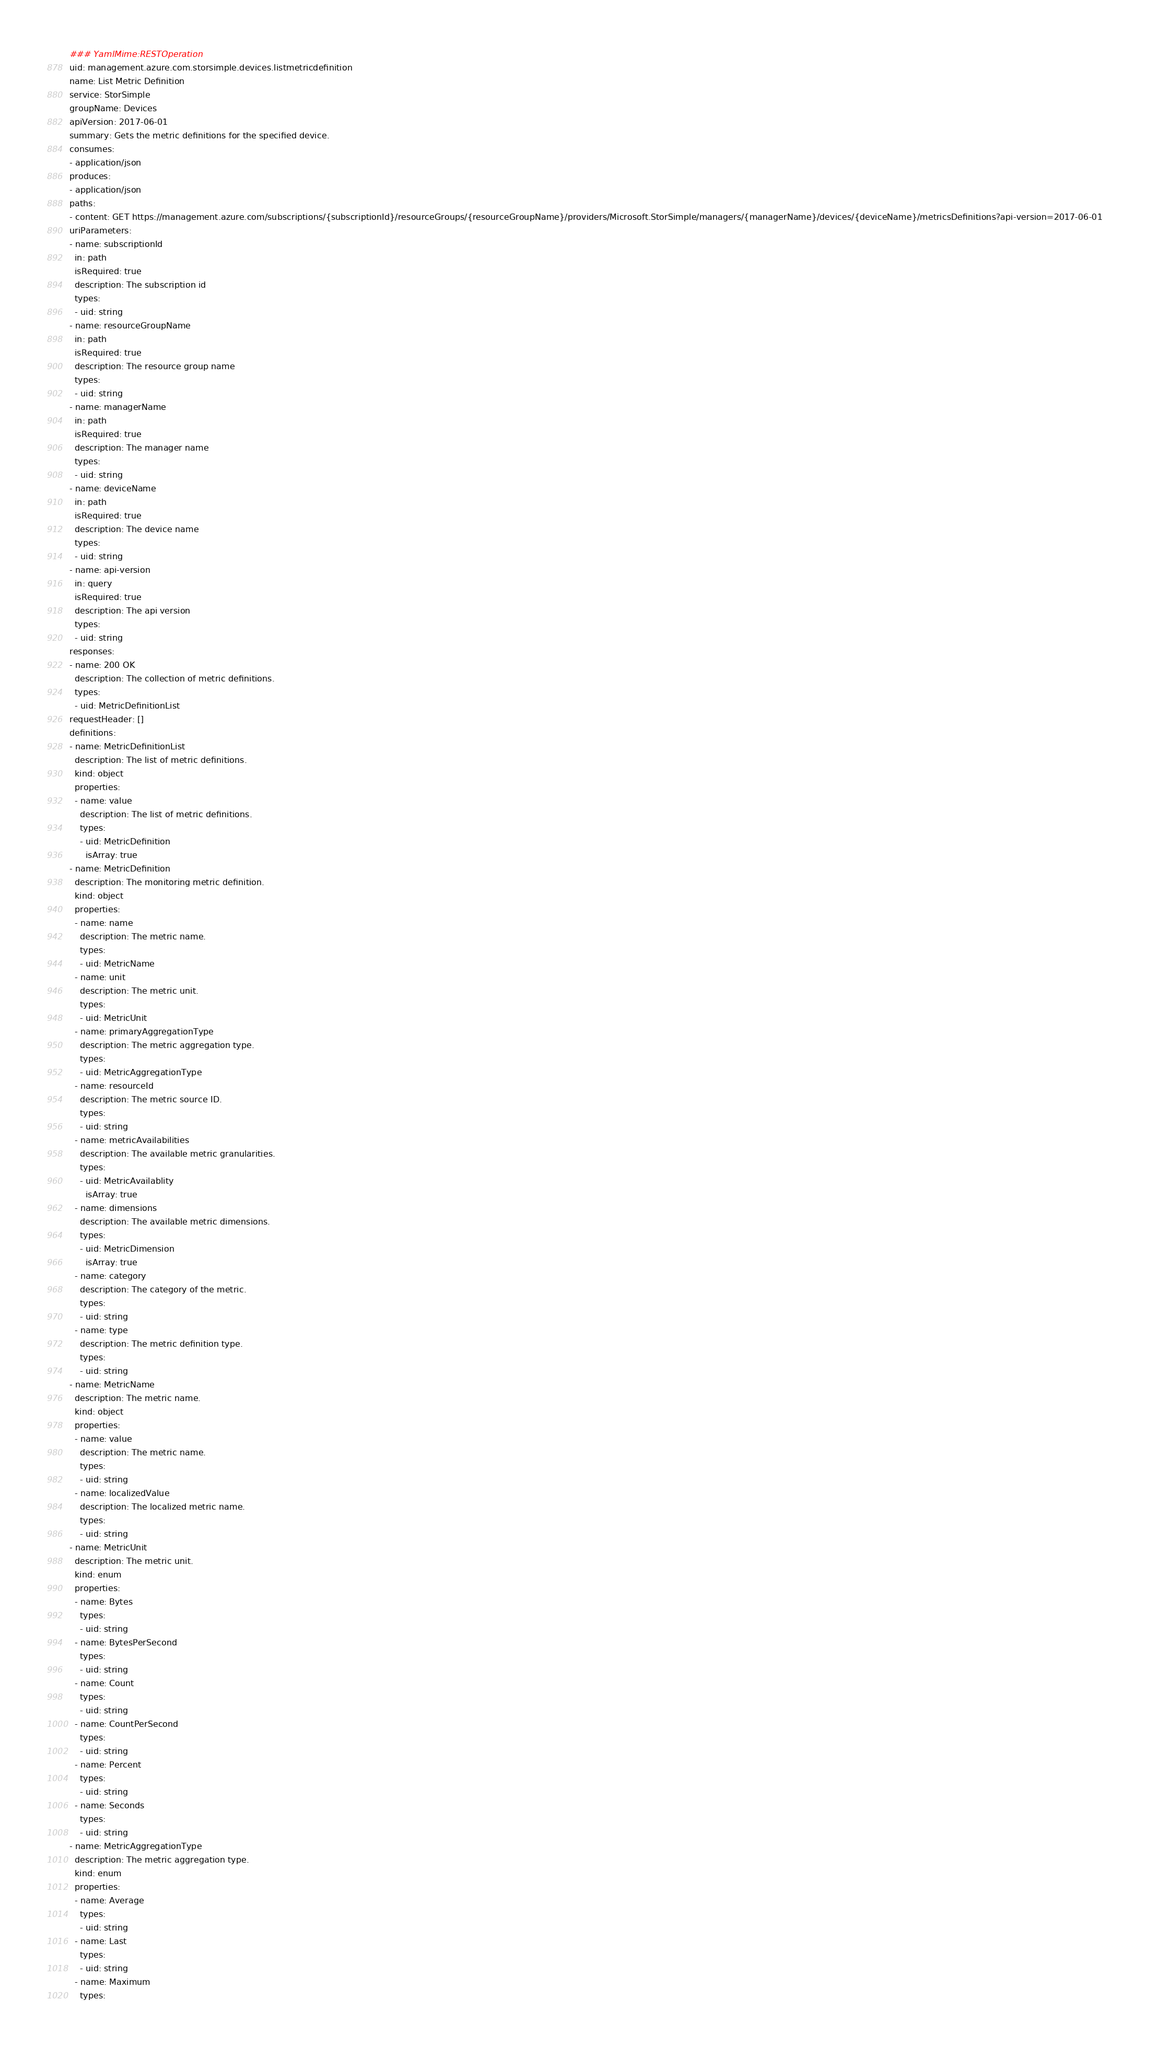<code> <loc_0><loc_0><loc_500><loc_500><_YAML_>### YamlMime:RESTOperation
uid: management.azure.com.storsimple.devices.listmetricdefinition
name: List Metric Definition
service: StorSimple
groupName: Devices
apiVersion: 2017-06-01
summary: Gets the metric definitions for the specified device.
consumes:
- application/json
produces:
- application/json
paths:
- content: GET https://management.azure.com/subscriptions/{subscriptionId}/resourceGroups/{resourceGroupName}/providers/Microsoft.StorSimple/managers/{managerName}/devices/{deviceName}/metricsDefinitions?api-version=2017-06-01
uriParameters:
- name: subscriptionId
  in: path
  isRequired: true
  description: The subscription id
  types:
  - uid: string
- name: resourceGroupName
  in: path
  isRequired: true
  description: The resource group name
  types:
  - uid: string
- name: managerName
  in: path
  isRequired: true
  description: The manager name
  types:
  - uid: string
- name: deviceName
  in: path
  isRequired: true
  description: The device name
  types:
  - uid: string
- name: api-version
  in: query
  isRequired: true
  description: The api version
  types:
  - uid: string
responses:
- name: 200 OK
  description: The collection of metric definitions.
  types:
  - uid: MetricDefinitionList
requestHeader: []
definitions:
- name: MetricDefinitionList
  description: The list of metric definitions.
  kind: object
  properties:
  - name: value
    description: The list of metric definitions.
    types:
    - uid: MetricDefinition
      isArray: true
- name: MetricDefinition
  description: The monitoring metric definition.
  kind: object
  properties:
  - name: name
    description: The metric name.
    types:
    - uid: MetricName
  - name: unit
    description: The metric unit.
    types:
    - uid: MetricUnit
  - name: primaryAggregationType
    description: The metric aggregation type.
    types:
    - uid: MetricAggregationType
  - name: resourceId
    description: The metric source ID.
    types:
    - uid: string
  - name: metricAvailabilities
    description: The available metric granularities.
    types:
    - uid: MetricAvailablity
      isArray: true
  - name: dimensions
    description: The available metric dimensions.
    types:
    - uid: MetricDimension
      isArray: true
  - name: category
    description: The category of the metric.
    types:
    - uid: string
  - name: type
    description: The metric definition type.
    types:
    - uid: string
- name: MetricName
  description: The metric name.
  kind: object
  properties:
  - name: value
    description: The metric name.
    types:
    - uid: string
  - name: localizedValue
    description: The localized metric name.
    types:
    - uid: string
- name: MetricUnit
  description: The metric unit.
  kind: enum
  properties:
  - name: Bytes
    types:
    - uid: string
  - name: BytesPerSecond
    types:
    - uid: string
  - name: Count
    types:
    - uid: string
  - name: CountPerSecond
    types:
    - uid: string
  - name: Percent
    types:
    - uid: string
  - name: Seconds
    types:
    - uid: string
- name: MetricAggregationType
  description: The metric aggregation type.
  kind: enum
  properties:
  - name: Average
    types:
    - uid: string
  - name: Last
    types:
    - uid: string
  - name: Maximum
    types:</code> 